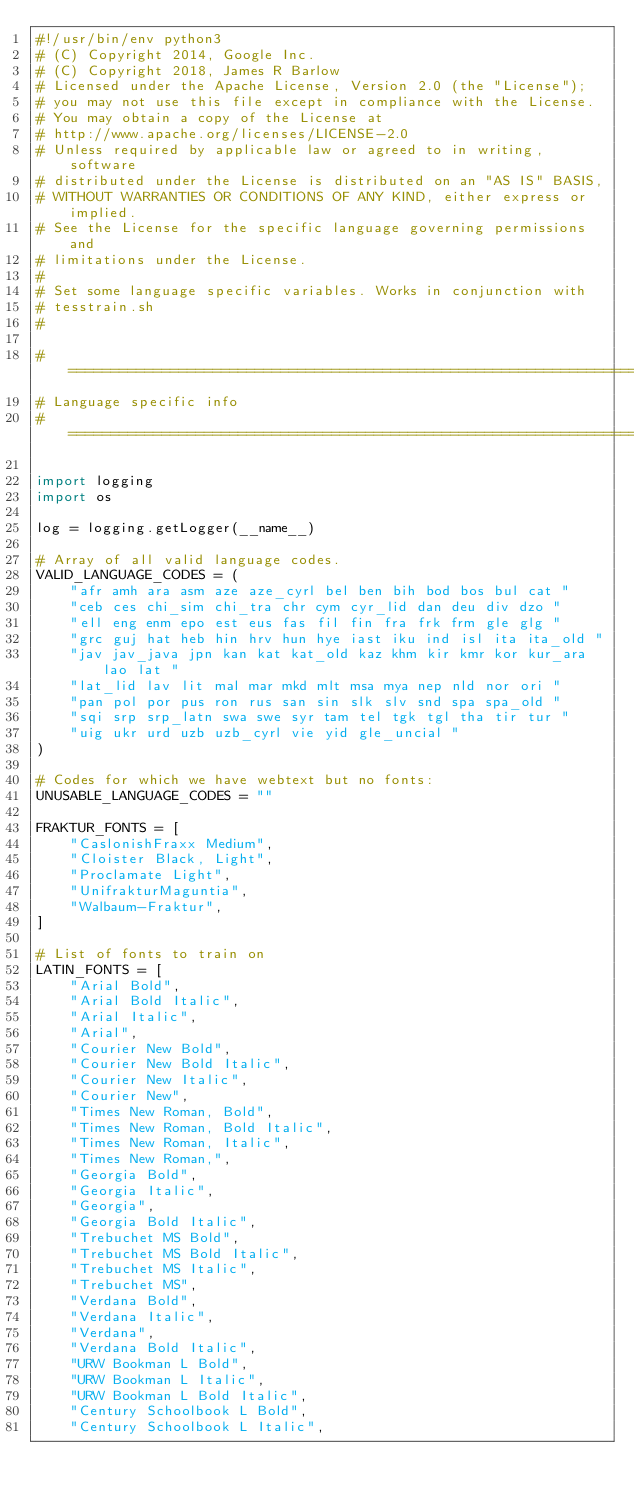<code> <loc_0><loc_0><loc_500><loc_500><_Python_>#!/usr/bin/env python3
# (C) Copyright 2014, Google Inc.
# (C) Copyright 2018, James R Barlow
# Licensed under the Apache License, Version 2.0 (the "License");
# you may not use this file except in compliance with the License.
# You may obtain a copy of the License at
# http://www.apache.org/licenses/LICENSE-2.0
# Unless required by applicable law or agreed to in writing, software
# distributed under the License is distributed on an "AS IS" BASIS,
# WITHOUT WARRANTIES OR CONDITIONS OF ANY KIND, either express or implied.
# See the License for the specific language governing permissions and
# limitations under the License.
#
# Set some language specific variables. Works in conjunction with
# tesstrain.sh
#

# =============================================================================
# Language specific info
# =============================================================================

import logging
import os

log = logging.getLogger(__name__)

# Array of all valid language codes.
VALID_LANGUAGE_CODES = (
    "afr amh ara asm aze aze_cyrl bel ben bih bod bos bul cat "
    "ceb ces chi_sim chi_tra chr cym cyr_lid dan deu div dzo "
    "ell eng enm epo est eus fas fil fin fra frk frm gle glg "
    "grc guj hat heb hin hrv hun hye iast iku ind isl ita ita_old "
    "jav jav_java jpn kan kat kat_old kaz khm kir kmr kor kur_ara lao lat "
    "lat_lid lav lit mal mar mkd mlt msa mya nep nld nor ori "
    "pan pol por pus ron rus san sin slk slv snd spa spa_old "
    "sqi srp srp_latn swa swe syr tam tel tgk tgl tha tir tur "
    "uig ukr urd uzb uzb_cyrl vie yid gle_uncial "
)

# Codes for which we have webtext but no fonts:
UNUSABLE_LANGUAGE_CODES = ""

FRAKTUR_FONTS = [
    "CaslonishFraxx Medium",
    "Cloister Black, Light",
    "Proclamate Light",
    "UnifrakturMaguntia",
    "Walbaum-Fraktur",
]

# List of fonts to train on
LATIN_FONTS = [
    "Arial Bold",
    "Arial Bold Italic",
    "Arial Italic",
    "Arial",
    "Courier New Bold",
    "Courier New Bold Italic",
    "Courier New Italic",
    "Courier New",
    "Times New Roman, Bold",
    "Times New Roman, Bold Italic",
    "Times New Roman, Italic",
    "Times New Roman,",
    "Georgia Bold",
    "Georgia Italic",
    "Georgia",
    "Georgia Bold Italic",
    "Trebuchet MS Bold",
    "Trebuchet MS Bold Italic",
    "Trebuchet MS Italic",
    "Trebuchet MS",
    "Verdana Bold",
    "Verdana Italic",
    "Verdana",
    "Verdana Bold Italic",
    "URW Bookman L Bold",
    "URW Bookman L Italic",
    "URW Bookman L Bold Italic",
    "Century Schoolbook L Bold",
    "Century Schoolbook L Italic",</code> 